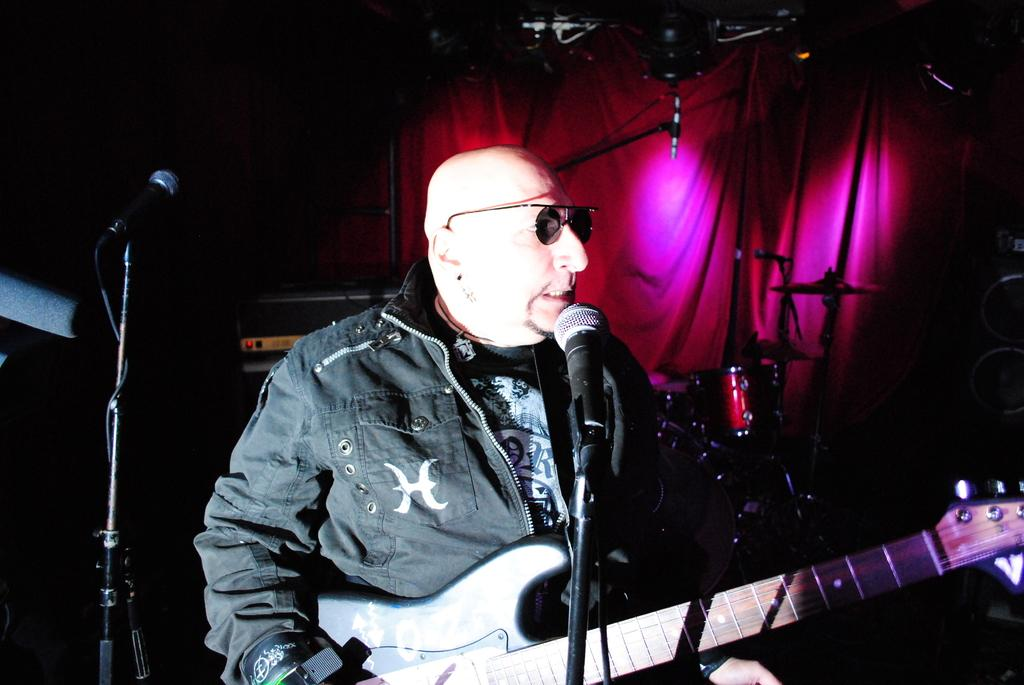What is the main subject of the image? There is a person in the image. What is the person doing in the image? The person is standing in front of a mic and holding a guitar. What can be seen in the background of the image? There is a curtain in the background of the image. What type of bomb is the person holding in the image? There is no bomb present in the image; the person is holding a guitar. Can you tell me how the dad is related to the person in the image? There is no information about a dad or any familial relationships in the image. 